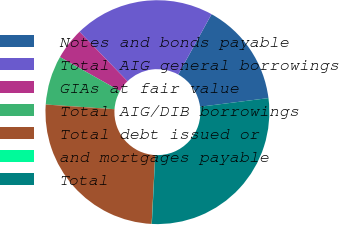Convert chart. <chart><loc_0><loc_0><loc_500><loc_500><pie_chart><fcel>Notes and bonds payable<fcel>Total AIG general borrowings<fcel>GIAs at fair value<fcel>Total AIG/DIB borrowings<fcel>Total debt issued or<fcel>and mortgages payable<fcel>Total<nl><fcel>14.96%<fcel>20.28%<fcel>4.57%<fcel>7.1%<fcel>25.27%<fcel>0.03%<fcel>27.79%<nl></chart> 